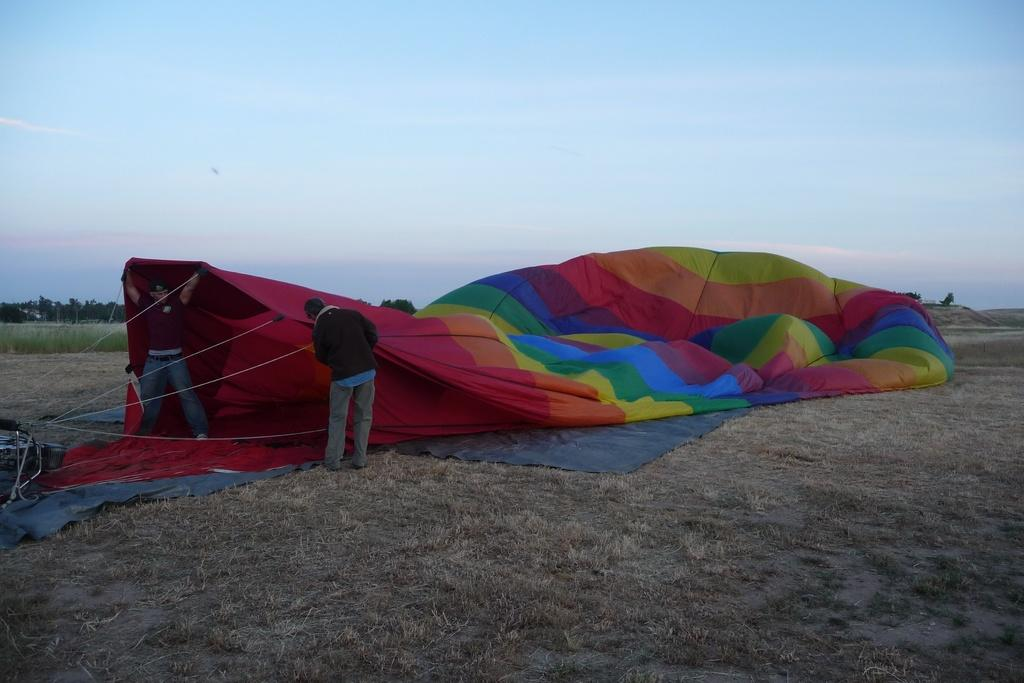What is the main object in the center of the image? There is a parachute in the center of the image. Where are the people located in the image? The people are standing on the left side of the image. What can be seen in the background of the image? There are trees, grass, and the sky visible in the background of the image. How much sugar is being used by the maid in the image? There is no maid or sugar present in the image. What type of crowd can be seen gathering around the parachute in the image? There is no crowd present in the image; only people standing on the left side. 